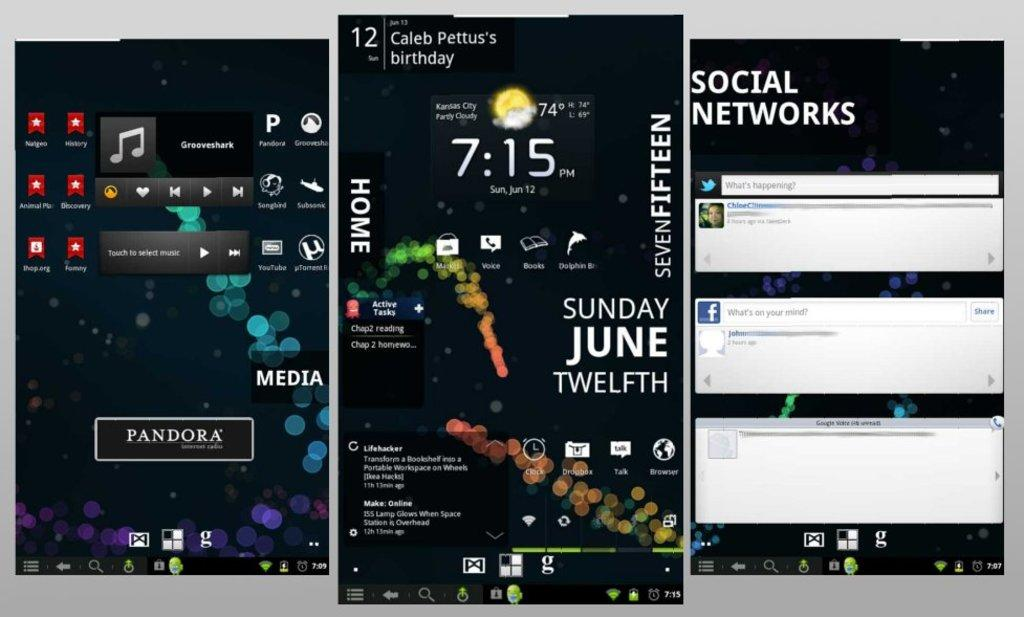Provide a one-sentence caption for the provided image. Phone applications shown in three different windows with different things pulled up. 